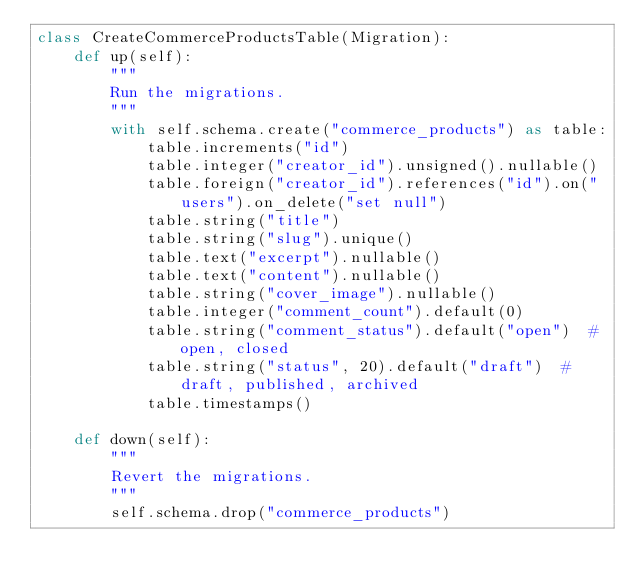<code> <loc_0><loc_0><loc_500><loc_500><_Python_>class CreateCommerceProductsTable(Migration):
    def up(self):
        """
        Run the migrations.
        """
        with self.schema.create("commerce_products") as table:
            table.increments("id")
            table.integer("creator_id").unsigned().nullable()
            table.foreign("creator_id").references("id").on("users").on_delete("set null")
            table.string("title")
            table.string("slug").unique()
            table.text("excerpt").nullable()
            table.text("content").nullable()
            table.string("cover_image").nullable()
            table.integer("comment_count").default(0)
            table.string("comment_status").default("open")  # open, closed
            table.string("status", 20).default("draft")  # draft, published, archived
            table.timestamps()

    def down(self):
        """
        Revert the migrations.
        """
        self.schema.drop("commerce_products")
</code> 